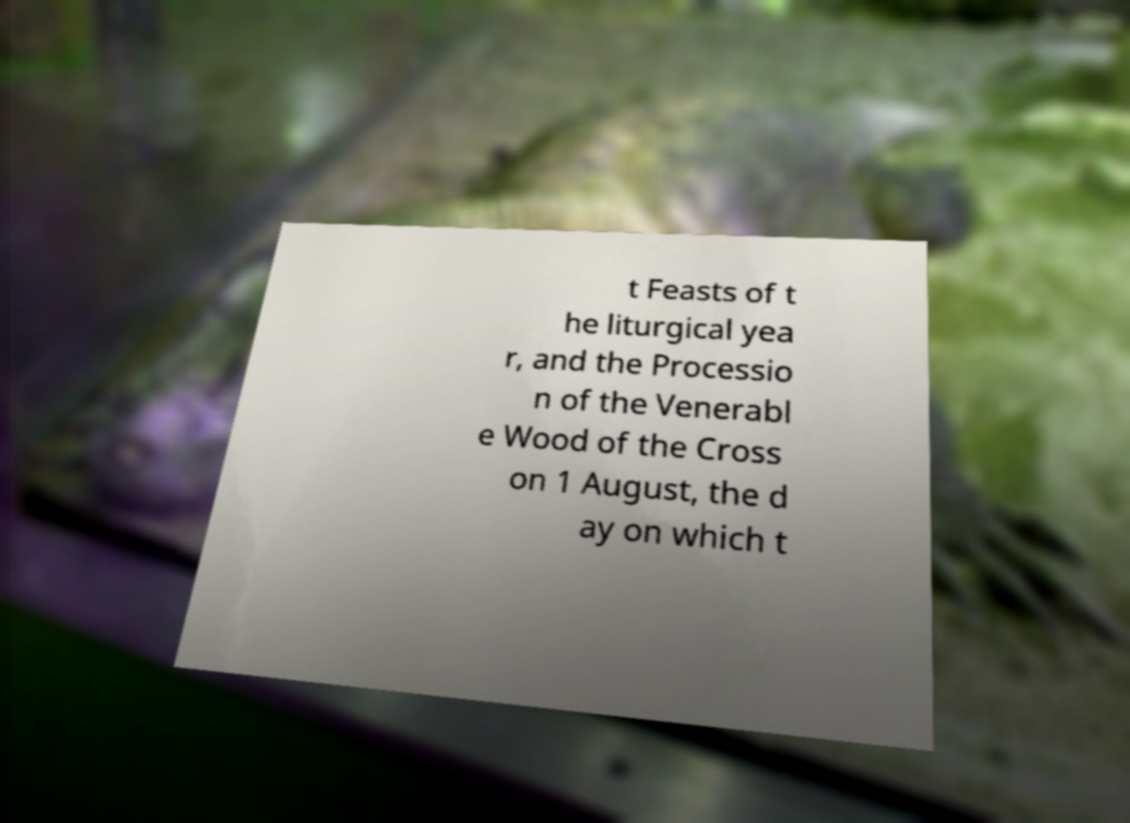Could you assist in decoding the text presented in this image and type it out clearly? t Feasts of t he liturgical yea r, and the Processio n of the Venerabl e Wood of the Cross on 1 August, the d ay on which t 